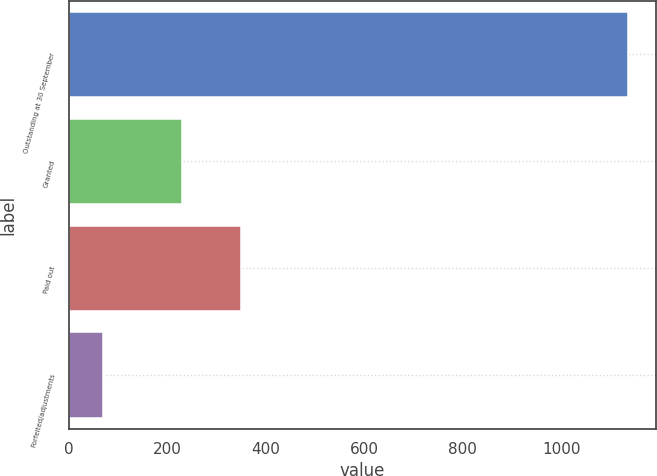Convert chart to OTSL. <chart><loc_0><loc_0><loc_500><loc_500><bar_chart><fcel>Outstanding at 30 September<fcel>Granted<fcel>Paid out<fcel>Forfeited/adjustments<nl><fcel>1136<fcel>229<fcel>348.6<fcel>68<nl></chart> 